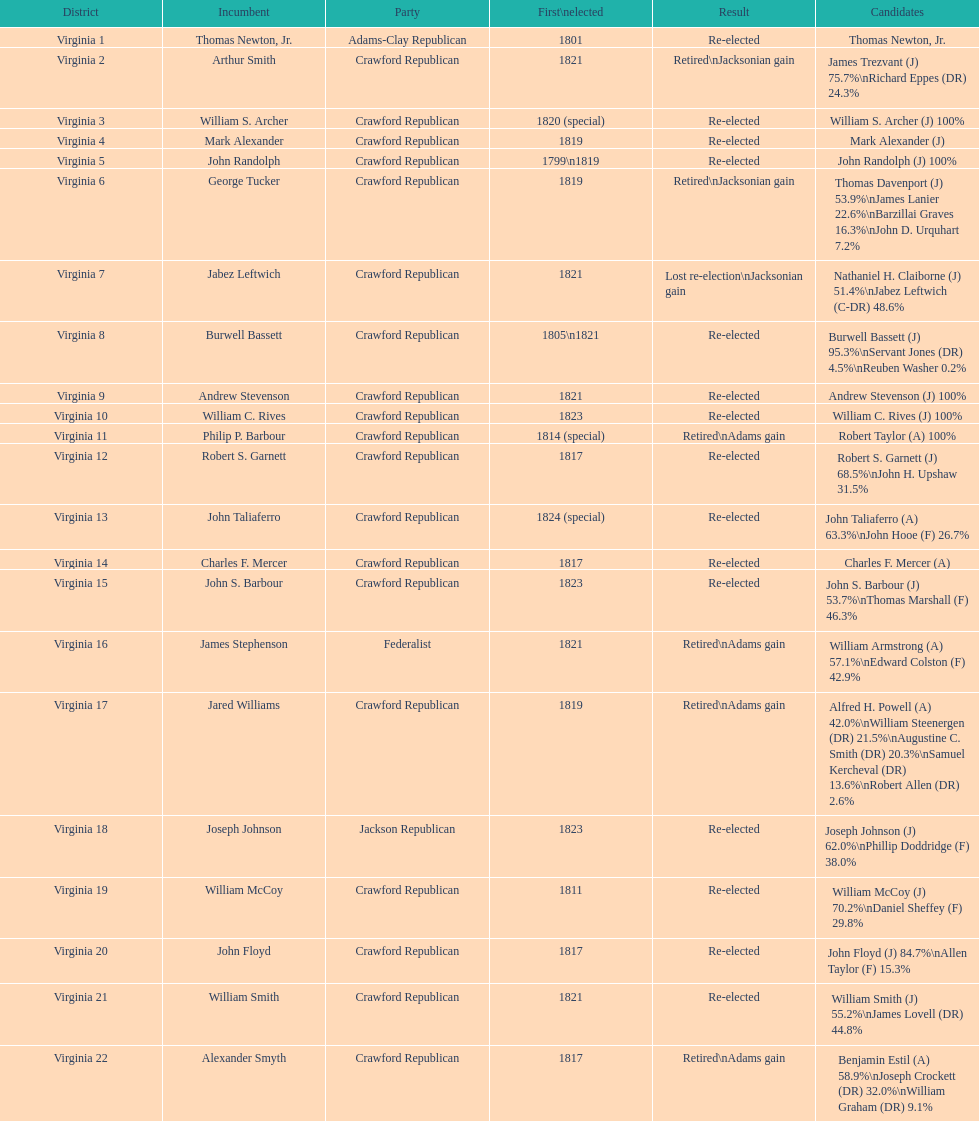Which party appears last on this chart? Crawford Republican. 